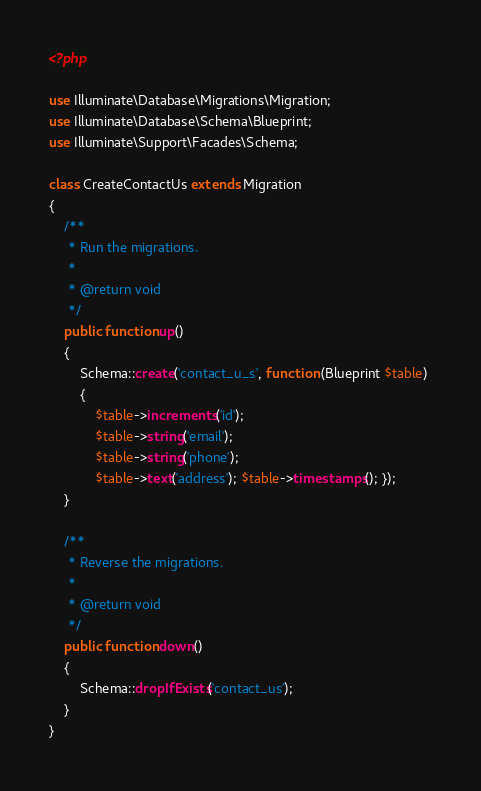<code> <loc_0><loc_0><loc_500><loc_500><_PHP_><?php

use Illuminate\Database\Migrations\Migration;
use Illuminate\Database\Schema\Blueprint;
use Illuminate\Support\Facades\Schema;

class CreateContactUs extends Migration
{
    /**
     * Run the migrations.
     *
     * @return void
     */
    public function up()
    {
        Schema::create('contact_u_s', function (Blueprint $table) 
        { 
            $table->increments('id'); 
            $table->string('email'); 
            $table->string('phone'); 
            $table->text('address'); $table->timestamps(); });
    }

    /**
     * Reverse the migrations.
     *
     * @return void
     */
    public function down()
    {
        Schema::dropIfExists('contact_us');
    }
}
</code> 